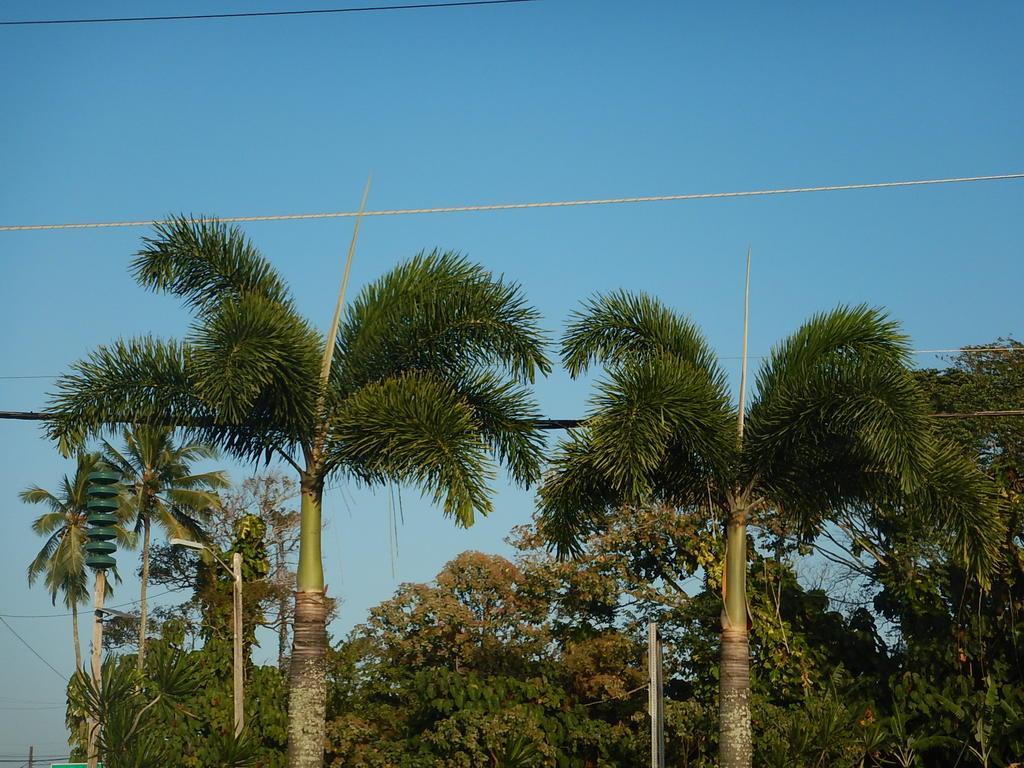Describe this image in one or two sentences. In this image we can see there are some tall trees and in the background there is blue sky. 